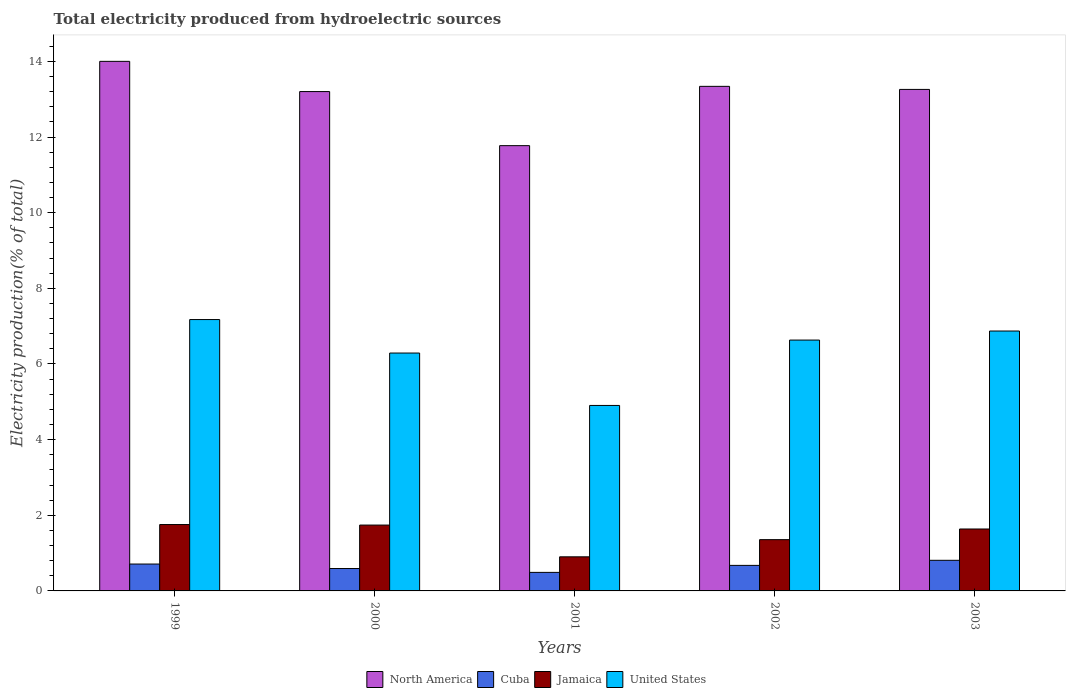How many different coloured bars are there?
Ensure brevity in your answer.  4. How many bars are there on the 3rd tick from the left?
Your response must be concise. 4. How many bars are there on the 5th tick from the right?
Ensure brevity in your answer.  4. What is the label of the 4th group of bars from the left?
Offer a terse response. 2002. What is the total electricity produced in North America in 2000?
Provide a succinct answer. 13.2. Across all years, what is the maximum total electricity produced in Cuba?
Your answer should be very brief. 0.81. Across all years, what is the minimum total electricity produced in Jamaica?
Your answer should be very brief. 0.9. In which year was the total electricity produced in Jamaica maximum?
Your response must be concise. 1999. In which year was the total electricity produced in United States minimum?
Your response must be concise. 2001. What is the total total electricity produced in United States in the graph?
Give a very brief answer. 31.87. What is the difference between the total electricity produced in Cuba in 2002 and that in 2003?
Provide a succinct answer. -0.13. What is the difference between the total electricity produced in Jamaica in 2000 and the total electricity produced in United States in 2001?
Keep it short and to the point. -3.16. What is the average total electricity produced in United States per year?
Keep it short and to the point. 6.37. In the year 2002, what is the difference between the total electricity produced in North America and total electricity produced in United States?
Offer a very short reply. 6.71. In how many years, is the total electricity produced in North America greater than 12.4 %?
Make the answer very short. 4. What is the ratio of the total electricity produced in Cuba in 2000 to that in 2002?
Your response must be concise. 0.88. Is the difference between the total electricity produced in North America in 2002 and 2003 greater than the difference between the total electricity produced in United States in 2002 and 2003?
Offer a very short reply. Yes. What is the difference between the highest and the second highest total electricity produced in Cuba?
Provide a succinct answer. 0.1. What is the difference between the highest and the lowest total electricity produced in United States?
Keep it short and to the point. 2.27. In how many years, is the total electricity produced in Jamaica greater than the average total electricity produced in Jamaica taken over all years?
Make the answer very short. 3. What does the 2nd bar from the left in 1999 represents?
Offer a very short reply. Cuba. What does the 1st bar from the right in 2001 represents?
Make the answer very short. United States. Is it the case that in every year, the sum of the total electricity produced in United States and total electricity produced in Jamaica is greater than the total electricity produced in North America?
Keep it short and to the point. No. How many bars are there?
Offer a terse response. 20. How many years are there in the graph?
Offer a very short reply. 5. Are the values on the major ticks of Y-axis written in scientific E-notation?
Provide a short and direct response. No. How many legend labels are there?
Provide a succinct answer. 4. How are the legend labels stacked?
Make the answer very short. Horizontal. What is the title of the graph?
Provide a succinct answer. Total electricity produced from hydroelectric sources. What is the Electricity production(% of total) in North America in 1999?
Ensure brevity in your answer.  14. What is the Electricity production(% of total) of Cuba in 1999?
Your response must be concise. 0.71. What is the Electricity production(% of total) of Jamaica in 1999?
Keep it short and to the point. 1.76. What is the Electricity production(% of total) in United States in 1999?
Provide a succinct answer. 7.17. What is the Electricity production(% of total) of North America in 2000?
Make the answer very short. 13.2. What is the Electricity production(% of total) of Cuba in 2000?
Keep it short and to the point. 0.59. What is the Electricity production(% of total) in Jamaica in 2000?
Give a very brief answer. 1.74. What is the Electricity production(% of total) of United States in 2000?
Ensure brevity in your answer.  6.29. What is the Electricity production(% of total) of North America in 2001?
Your answer should be very brief. 11.77. What is the Electricity production(% of total) of Cuba in 2001?
Your answer should be very brief. 0.49. What is the Electricity production(% of total) in Jamaica in 2001?
Offer a terse response. 0.9. What is the Electricity production(% of total) in United States in 2001?
Offer a terse response. 4.9. What is the Electricity production(% of total) in North America in 2002?
Your answer should be very brief. 13.34. What is the Electricity production(% of total) in Cuba in 2002?
Your response must be concise. 0.68. What is the Electricity production(% of total) in Jamaica in 2002?
Your response must be concise. 1.36. What is the Electricity production(% of total) of United States in 2002?
Give a very brief answer. 6.63. What is the Electricity production(% of total) in North America in 2003?
Provide a succinct answer. 13.26. What is the Electricity production(% of total) in Cuba in 2003?
Your answer should be very brief. 0.81. What is the Electricity production(% of total) of Jamaica in 2003?
Your answer should be very brief. 1.64. What is the Electricity production(% of total) in United States in 2003?
Provide a short and direct response. 6.87. Across all years, what is the maximum Electricity production(% of total) in North America?
Make the answer very short. 14. Across all years, what is the maximum Electricity production(% of total) in Cuba?
Your response must be concise. 0.81. Across all years, what is the maximum Electricity production(% of total) of Jamaica?
Offer a terse response. 1.76. Across all years, what is the maximum Electricity production(% of total) of United States?
Give a very brief answer. 7.17. Across all years, what is the minimum Electricity production(% of total) of North America?
Your answer should be compact. 11.77. Across all years, what is the minimum Electricity production(% of total) in Cuba?
Offer a very short reply. 0.49. Across all years, what is the minimum Electricity production(% of total) in Jamaica?
Your response must be concise. 0.9. Across all years, what is the minimum Electricity production(% of total) in United States?
Ensure brevity in your answer.  4.9. What is the total Electricity production(% of total) of North America in the graph?
Give a very brief answer. 65.58. What is the total Electricity production(% of total) in Cuba in the graph?
Ensure brevity in your answer.  3.28. What is the total Electricity production(% of total) in Jamaica in the graph?
Offer a very short reply. 7.39. What is the total Electricity production(% of total) of United States in the graph?
Ensure brevity in your answer.  31.87. What is the difference between the Electricity production(% of total) in North America in 1999 and that in 2000?
Offer a terse response. 0.8. What is the difference between the Electricity production(% of total) in Cuba in 1999 and that in 2000?
Provide a short and direct response. 0.12. What is the difference between the Electricity production(% of total) in Jamaica in 1999 and that in 2000?
Ensure brevity in your answer.  0.01. What is the difference between the Electricity production(% of total) in United States in 1999 and that in 2000?
Keep it short and to the point. 0.89. What is the difference between the Electricity production(% of total) of North America in 1999 and that in 2001?
Ensure brevity in your answer.  2.23. What is the difference between the Electricity production(% of total) of Cuba in 1999 and that in 2001?
Give a very brief answer. 0.22. What is the difference between the Electricity production(% of total) of Jamaica in 1999 and that in 2001?
Offer a terse response. 0.85. What is the difference between the Electricity production(% of total) of United States in 1999 and that in 2001?
Make the answer very short. 2.27. What is the difference between the Electricity production(% of total) in North America in 1999 and that in 2002?
Make the answer very short. 0.66. What is the difference between the Electricity production(% of total) in Cuba in 1999 and that in 2002?
Offer a very short reply. 0.04. What is the difference between the Electricity production(% of total) in Jamaica in 1999 and that in 2002?
Offer a terse response. 0.4. What is the difference between the Electricity production(% of total) of United States in 1999 and that in 2002?
Your response must be concise. 0.54. What is the difference between the Electricity production(% of total) of North America in 1999 and that in 2003?
Your answer should be very brief. 0.74. What is the difference between the Electricity production(% of total) in Cuba in 1999 and that in 2003?
Offer a very short reply. -0.1. What is the difference between the Electricity production(% of total) in Jamaica in 1999 and that in 2003?
Ensure brevity in your answer.  0.12. What is the difference between the Electricity production(% of total) of United States in 1999 and that in 2003?
Offer a very short reply. 0.3. What is the difference between the Electricity production(% of total) in North America in 2000 and that in 2001?
Your answer should be very brief. 1.43. What is the difference between the Electricity production(% of total) of Cuba in 2000 and that in 2001?
Offer a terse response. 0.1. What is the difference between the Electricity production(% of total) in Jamaica in 2000 and that in 2001?
Your answer should be very brief. 0.84. What is the difference between the Electricity production(% of total) of United States in 2000 and that in 2001?
Provide a succinct answer. 1.39. What is the difference between the Electricity production(% of total) in North America in 2000 and that in 2002?
Provide a succinct answer. -0.14. What is the difference between the Electricity production(% of total) of Cuba in 2000 and that in 2002?
Ensure brevity in your answer.  -0.08. What is the difference between the Electricity production(% of total) in Jamaica in 2000 and that in 2002?
Make the answer very short. 0.39. What is the difference between the Electricity production(% of total) in United States in 2000 and that in 2002?
Offer a terse response. -0.34. What is the difference between the Electricity production(% of total) in North America in 2000 and that in 2003?
Make the answer very short. -0.06. What is the difference between the Electricity production(% of total) in Cuba in 2000 and that in 2003?
Your answer should be very brief. -0.22. What is the difference between the Electricity production(% of total) in Jamaica in 2000 and that in 2003?
Make the answer very short. 0.1. What is the difference between the Electricity production(% of total) of United States in 2000 and that in 2003?
Your answer should be very brief. -0.58. What is the difference between the Electricity production(% of total) of North America in 2001 and that in 2002?
Ensure brevity in your answer.  -1.57. What is the difference between the Electricity production(% of total) in Cuba in 2001 and that in 2002?
Give a very brief answer. -0.18. What is the difference between the Electricity production(% of total) in Jamaica in 2001 and that in 2002?
Your answer should be very brief. -0.45. What is the difference between the Electricity production(% of total) of United States in 2001 and that in 2002?
Make the answer very short. -1.73. What is the difference between the Electricity production(% of total) of North America in 2001 and that in 2003?
Your answer should be very brief. -1.49. What is the difference between the Electricity production(% of total) in Cuba in 2001 and that in 2003?
Your answer should be compact. -0.32. What is the difference between the Electricity production(% of total) in Jamaica in 2001 and that in 2003?
Keep it short and to the point. -0.74. What is the difference between the Electricity production(% of total) of United States in 2001 and that in 2003?
Keep it short and to the point. -1.97. What is the difference between the Electricity production(% of total) in North America in 2002 and that in 2003?
Make the answer very short. 0.08. What is the difference between the Electricity production(% of total) of Cuba in 2002 and that in 2003?
Offer a very short reply. -0.13. What is the difference between the Electricity production(% of total) of Jamaica in 2002 and that in 2003?
Your answer should be very brief. -0.28. What is the difference between the Electricity production(% of total) in United States in 2002 and that in 2003?
Provide a succinct answer. -0.24. What is the difference between the Electricity production(% of total) in North America in 1999 and the Electricity production(% of total) in Cuba in 2000?
Give a very brief answer. 13.41. What is the difference between the Electricity production(% of total) in North America in 1999 and the Electricity production(% of total) in Jamaica in 2000?
Your answer should be very brief. 12.26. What is the difference between the Electricity production(% of total) of North America in 1999 and the Electricity production(% of total) of United States in 2000?
Provide a short and direct response. 7.71. What is the difference between the Electricity production(% of total) of Cuba in 1999 and the Electricity production(% of total) of Jamaica in 2000?
Your answer should be very brief. -1.03. What is the difference between the Electricity production(% of total) of Cuba in 1999 and the Electricity production(% of total) of United States in 2000?
Give a very brief answer. -5.58. What is the difference between the Electricity production(% of total) in Jamaica in 1999 and the Electricity production(% of total) in United States in 2000?
Offer a very short reply. -4.53. What is the difference between the Electricity production(% of total) in North America in 1999 and the Electricity production(% of total) in Cuba in 2001?
Keep it short and to the point. 13.51. What is the difference between the Electricity production(% of total) of North America in 1999 and the Electricity production(% of total) of Jamaica in 2001?
Make the answer very short. 13.1. What is the difference between the Electricity production(% of total) in North America in 1999 and the Electricity production(% of total) in United States in 2001?
Ensure brevity in your answer.  9.1. What is the difference between the Electricity production(% of total) in Cuba in 1999 and the Electricity production(% of total) in Jamaica in 2001?
Your answer should be very brief. -0.19. What is the difference between the Electricity production(% of total) of Cuba in 1999 and the Electricity production(% of total) of United States in 2001?
Offer a terse response. -4.19. What is the difference between the Electricity production(% of total) in Jamaica in 1999 and the Electricity production(% of total) in United States in 2001?
Keep it short and to the point. -3.15. What is the difference between the Electricity production(% of total) of North America in 1999 and the Electricity production(% of total) of Cuba in 2002?
Provide a short and direct response. 13.33. What is the difference between the Electricity production(% of total) of North America in 1999 and the Electricity production(% of total) of Jamaica in 2002?
Offer a terse response. 12.65. What is the difference between the Electricity production(% of total) of North America in 1999 and the Electricity production(% of total) of United States in 2002?
Give a very brief answer. 7.37. What is the difference between the Electricity production(% of total) of Cuba in 1999 and the Electricity production(% of total) of Jamaica in 2002?
Your response must be concise. -0.64. What is the difference between the Electricity production(% of total) of Cuba in 1999 and the Electricity production(% of total) of United States in 2002?
Provide a short and direct response. -5.92. What is the difference between the Electricity production(% of total) of Jamaica in 1999 and the Electricity production(% of total) of United States in 2002?
Ensure brevity in your answer.  -4.88. What is the difference between the Electricity production(% of total) in North America in 1999 and the Electricity production(% of total) in Cuba in 2003?
Ensure brevity in your answer.  13.19. What is the difference between the Electricity production(% of total) in North America in 1999 and the Electricity production(% of total) in Jamaica in 2003?
Make the answer very short. 12.36. What is the difference between the Electricity production(% of total) of North America in 1999 and the Electricity production(% of total) of United States in 2003?
Provide a succinct answer. 7.13. What is the difference between the Electricity production(% of total) in Cuba in 1999 and the Electricity production(% of total) in Jamaica in 2003?
Provide a succinct answer. -0.93. What is the difference between the Electricity production(% of total) of Cuba in 1999 and the Electricity production(% of total) of United States in 2003?
Provide a short and direct response. -6.16. What is the difference between the Electricity production(% of total) of Jamaica in 1999 and the Electricity production(% of total) of United States in 2003?
Provide a succinct answer. -5.12. What is the difference between the Electricity production(% of total) of North America in 2000 and the Electricity production(% of total) of Cuba in 2001?
Your response must be concise. 12.71. What is the difference between the Electricity production(% of total) of North America in 2000 and the Electricity production(% of total) of Jamaica in 2001?
Ensure brevity in your answer.  12.3. What is the difference between the Electricity production(% of total) in North America in 2000 and the Electricity production(% of total) in United States in 2001?
Provide a short and direct response. 8.3. What is the difference between the Electricity production(% of total) of Cuba in 2000 and the Electricity production(% of total) of Jamaica in 2001?
Your answer should be very brief. -0.31. What is the difference between the Electricity production(% of total) in Cuba in 2000 and the Electricity production(% of total) in United States in 2001?
Ensure brevity in your answer.  -4.31. What is the difference between the Electricity production(% of total) in Jamaica in 2000 and the Electricity production(% of total) in United States in 2001?
Keep it short and to the point. -3.16. What is the difference between the Electricity production(% of total) in North America in 2000 and the Electricity production(% of total) in Cuba in 2002?
Offer a terse response. 12.53. What is the difference between the Electricity production(% of total) of North America in 2000 and the Electricity production(% of total) of Jamaica in 2002?
Keep it short and to the point. 11.85. What is the difference between the Electricity production(% of total) in North America in 2000 and the Electricity production(% of total) in United States in 2002?
Ensure brevity in your answer.  6.57. What is the difference between the Electricity production(% of total) in Cuba in 2000 and the Electricity production(% of total) in Jamaica in 2002?
Keep it short and to the point. -0.76. What is the difference between the Electricity production(% of total) of Cuba in 2000 and the Electricity production(% of total) of United States in 2002?
Make the answer very short. -6.04. What is the difference between the Electricity production(% of total) of Jamaica in 2000 and the Electricity production(% of total) of United States in 2002?
Your answer should be very brief. -4.89. What is the difference between the Electricity production(% of total) of North America in 2000 and the Electricity production(% of total) of Cuba in 2003?
Provide a succinct answer. 12.39. What is the difference between the Electricity production(% of total) of North America in 2000 and the Electricity production(% of total) of Jamaica in 2003?
Offer a terse response. 11.56. What is the difference between the Electricity production(% of total) of North America in 2000 and the Electricity production(% of total) of United States in 2003?
Make the answer very short. 6.33. What is the difference between the Electricity production(% of total) in Cuba in 2000 and the Electricity production(% of total) in Jamaica in 2003?
Offer a very short reply. -1.05. What is the difference between the Electricity production(% of total) in Cuba in 2000 and the Electricity production(% of total) in United States in 2003?
Provide a succinct answer. -6.28. What is the difference between the Electricity production(% of total) of Jamaica in 2000 and the Electricity production(% of total) of United States in 2003?
Your response must be concise. -5.13. What is the difference between the Electricity production(% of total) in North America in 2001 and the Electricity production(% of total) in Cuba in 2002?
Your answer should be compact. 11.1. What is the difference between the Electricity production(% of total) in North America in 2001 and the Electricity production(% of total) in Jamaica in 2002?
Provide a succinct answer. 10.42. What is the difference between the Electricity production(% of total) of North America in 2001 and the Electricity production(% of total) of United States in 2002?
Your answer should be compact. 5.14. What is the difference between the Electricity production(% of total) in Cuba in 2001 and the Electricity production(% of total) in Jamaica in 2002?
Offer a very short reply. -0.87. What is the difference between the Electricity production(% of total) in Cuba in 2001 and the Electricity production(% of total) in United States in 2002?
Give a very brief answer. -6.14. What is the difference between the Electricity production(% of total) in Jamaica in 2001 and the Electricity production(% of total) in United States in 2002?
Your response must be concise. -5.73. What is the difference between the Electricity production(% of total) of North America in 2001 and the Electricity production(% of total) of Cuba in 2003?
Give a very brief answer. 10.96. What is the difference between the Electricity production(% of total) in North America in 2001 and the Electricity production(% of total) in Jamaica in 2003?
Your answer should be very brief. 10.14. What is the difference between the Electricity production(% of total) in North America in 2001 and the Electricity production(% of total) in United States in 2003?
Your answer should be very brief. 4.9. What is the difference between the Electricity production(% of total) of Cuba in 2001 and the Electricity production(% of total) of Jamaica in 2003?
Give a very brief answer. -1.15. What is the difference between the Electricity production(% of total) in Cuba in 2001 and the Electricity production(% of total) in United States in 2003?
Your answer should be compact. -6.38. What is the difference between the Electricity production(% of total) in Jamaica in 2001 and the Electricity production(% of total) in United States in 2003?
Your answer should be compact. -5.97. What is the difference between the Electricity production(% of total) in North America in 2002 and the Electricity production(% of total) in Cuba in 2003?
Ensure brevity in your answer.  12.53. What is the difference between the Electricity production(% of total) of North America in 2002 and the Electricity production(% of total) of Jamaica in 2003?
Offer a very short reply. 11.7. What is the difference between the Electricity production(% of total) of North America in 2002 and the Electricity production(% of total) of United States in 2003?
Your answer should be compact. 6.47. What is the difference between the Electricity production(% of total) in Cuba in 2002 and the Electricity production(% of total) in Jamaica in 2003?
Give a very brief answer. -0.96. What is the difference between the Electricity production(% of total) in Cuba in 2002 and the Electricity production(% of total) in United States in 2003?
Keep it short and to the point. -6.2. What is the difference between the Electricity production(% of total) of Jamaica in 2002 and the Electricity production(% of total) of United States in 2003?
Ensure brevity in your answer.  -5.52. What is the average Electricity production(% of total) in North America per year?
Your response must be concise. 13.12. What is the average Electricity production(% of total) of Cuba per year?
Offer a terse response. 0.66. What is the average Electricity production(% of total) in Jamaica per year?
Offer a very short reply. 1.48. What is the average Electricity production(% of total) of United States per year?
Provide a succinct answer. 6.37. In the year 1999, what is the difference between the Electricity production(% of total) in North America and Electricity production(% of total) in Cuba?
Give a very brief answer. 13.29. In the year 1999, what is the difference between the Electricity production(% of total) of North America and Electricity production(% of total) of Jamaica?
Your answer should be compact. 12.25. In the year 1999, what is the difference between the Electricity production(% of total) in North America and Electricity production(% of total) in United States?
Offer a terse response. 6.83. In the year 1999, what is the difference between the Electricity production(% of total) in Cuba and Electricity production(% of total) in Jamaica?
Your response must be concise. -1.04. In the year 1999, what is the difference between the Electricity production(% of total) of Cuba and Electricity production(% of total) of United States?
Offer a terse response. -6.46. In the year 1999, what is the difference between the Electricity production(% of total) of Jamaica and Electricity production(% of total) of United States?
Your answer should be very brief. -5.42. In the year 2000, what is the difference between the Electricity production(% of total) in North America and Electricity production(% of total) in Cuba?
Offer a very short reply. 12.61. In the year 2000, what is the difference between the Electricity production(% of total) of North America and Electricity production(% of total) of Jamaica?
Offer a very short reply. 11.46. In the year 2000, what is the difference between the Electricity production(% of total) in North America and Electricity production(% of total) in United States?
Provide a succinct answer. 6.91. In the year 2000, what is the difference between the Electricity production(% of total) in Cuba and Electricity production(% of total) in Jamaica?
Keep it short and to the point. -1.15. In the year 2000, what is the difference between the Electricity production(% of total) in Cuba and Electricity production(% of total) in United States?
Keep it short and to the point. -5.7. In the year 2000, what is the difference between the Electricity production(% of total) of Jamaica and Electricity production(% of total) of United States?
Offer a terse response. -4.55. In the year 2001, what is the difference between the Electricity production(% of total) in North America and Electricity production(% of total) in Cuba?
Make the answer very short. 11.28. In the year 2001, what is the difference between the Electricity production(% of total) in North America and Electricity production(% of total) in Jamaica?
Give a very brief answer. 10.87. In the year 2001, what is the difference between the Electricity production(% of total) of North America and Electricity production(% of total) of United States?
Provide a succinct answer. 6.87. In the year 2001, what is the difference between the Electricity production(% of total) of Cuba and Electricity production(% of total) of Jamaica?
Provide a succinct answer. -0.41. In the year 2001, what is the difference between the Electricity production(% of total) in Cuba and Electricity production(% of total) in United States?
Provide a short and direct response. -4.41. In the year 2001, what is the difference between the Electricity production(% of total) of Jamaica and Electricity production(% of total) of United States?
Keep it short and to the point. -4. In the year 2002, what is the difference between the Electricity production(% of total) in North America and Electricity production(% of total) in Cuba?
Offer a very short reply. 12.67. In the year 2002, what is the difference between the Electricity production(% of total) of North America and Electricity production(% of total) of Jamaica?
Your answer should be compact. 11.98. In the year 2002, what is the difference between the Electricity production(% of total) of North America and Electricity production(% of total) of United States?
Your answer should be compact. 6.71. In the year 2002, what is the difference between the Electricity production(% of total) in Cuba and Electricity production(% of total) in Jamaica?
Give a very brief answer. -0.68. In the year 2002, what is the difference between the Electricity production(% of total) of Cuba and Electricity production(% of total) of United States?
Keep it short and to the point. -5.96. In the year 2002, what is the difference between the Electricity production(% of total) of Jamaica and Electricity production(% of total) of United States?
Offer a terse response. -5.28. In the year 2003, what is the difference between the Electricity production(% of total) of North America and Electricity production(% of total) of Cuba?
Your answer should be compact. 12.45. In the year 2003, what is the difference between the Electricity production(% of total) in North America and Electricity production(% of total) in Jamaica?
Offer a very short reply. 11.62. In the year 2003, what is the difference between the Electricity production(% of total) in North America and Electricity production(% of total) in United States?
Provide a succinct answer. 6.39. In the year 2003, what is the difference between the Electricity production(% of total) in Cuba and Electricity production(% of total) in Jamaica?
Your answer should be very brief. -0.83. In the year 2003, what is the difference between the Electricity production(% of total) of Cuba and Electricity production(% of total) of United States?
Your answer should be very brief. -6.06. In the year 2003, what is the difference between the Electricity production(% of total) of Jamaica and Electricity production(% of total) of United States?
Your answer should be very brief. -5.23. What is the ratio of the Electricity production(% of total) in North America in 1999 to that in 2000?
Your answer should be very brief. 1.06. What is the ratio of the Electricity production(% of total) of Cuba in 1999 to that in 2000?
Ensure brevity in your answer.  1.2. What is the ratio of the Electricity production(% of total) in Jamaica in 1999 to that in 2000?
Keep it short and to the point. 1.01. What is the ratio of the Electricity production(% of total) in United States in 1999 to that in 2000?
Offer a very short reply. 1.14. What is the ratio of the Electricity production(% of total) in North America in 1999 to that in 2001?
Your answer should be compact. 1.19. What is the ratio of the Electricity production(% of total) of Cuba in 1999 to that in 2001?
Ensure brevity in your answer.  1.45. What is the ratio of the Electricity production(% of total) in Jamaica in 1999 to that in 2001?
Keep it short and to the point. 1.95. What is the ratio of the Electricity production(% of total) of United States in 1999 to that in 2001?
Make the answer very short. 1.46. What is the ratio of the Electricity production(% of total) in North America in 1999 to that in 2002?
Provide a succinct answer. 1.05. What is the ratio of the Electricity production(% of total) in Cuba in 1999 to that in 2002?
Give a very brief answer. 1.05. What is the ratio of the Electricity production(% of total) in Jamaica in 1999 to that in 2002?
Your response must be concise. 1.29. What is the ratio of the Electricity production(% of total) in United States in 1999 to that in 2002?
Make the answer very short. 1.08. What is the ratio of the Electricity production(% of total) in North America in 1999 to that in 2003?
Provide a succinct answer. 1.06. What is the ratio of the Electricity production(% of total) of Cuba in 1999 to that in 2003?
Ensure brevity in your answer.  0.88. What is the ratio of the Electricity production(% of total) of Jamaica in 1999 to that in 2003?
Make the answer very short. 1.07. What is the ratio of the Electricity production(% of total) of United States in 1999 to that in 2003?
Keep it short and to the point. 1.04. What is the ratio of the Electricity production(% of total) of North America in 2000 to that in 2001?
Offer a very short reply. 1.12. What is the ratio of the Electricity production(% of total) of Cuba in 2000 to that in 2001?
Offer a very short reply. 1.21. What is the ratio of the Electricity production(% of total) in Jamaica in 2000 to that in 2001?
Offer a terse response. 1.93. What is the ratio of the Electricity production(% of total) of United States in 2000 to that in 2001?
Offer a terse response. 1.28. What is the ratio of the Electricity production(% of total) of North America in 2000 to that in 2002?
Your answer should be compact. 0.99. What is the ratio of the Electricity production(% of total) of Cuba in 2000 to that in 2002?
Offer a very short reply. 0.88. What is the ratio of the Electricity production(% of total) of Jamaica in 2000 to that in 2002?
Give a very brief answer. 1.28. What is the ratio of the Electricity production(% of total) of United States in 2000 to that in 2002?
Provide a short and direct response. 0.95. What is the ratio of the Electricity production(% of total) in Cuba in 2000 to that in 2003?
Offer a terse response. 0.73. What is the ratio of the Electricity production(% of total) in Jamaica in 2000 to that in 2003?
Give a very brief answer. 1.06. What is the ratio of the Electricity production(% of total) in United States in 2000 to that in 2003?
Make the answer very short. 0.92. What is the ratio of the Electricity production(% of total) in North America in 2001 to that in 2002?
Your answer should be very brief. 0.88. What is the ratio of the Electricity production(% of total) in Cuba in 2001 to that in 2002?
Keep it short and to the point. 0.73. What is the ratio of the Electricity production(% of total) in Jamaica in 2001 to that in 2002?
Your answer should be compact. 0.67. What is the ratio of the Electricity production(% of total) of United States in 2001 to that in 2002?
Offer a terse response. 0.74. What is the ratio of the Electricity production(% of total) of North America in 2001 to that in 2003?
Your response must be concise. 0.89. What is the ratio of the Electricity production(% of total) of Cuba in 2001 to that in 2003?
Offer a terse response. 0.61. What is the ratio of the Electricity production(% of total) of Jamaica in 2001 to that in 2003?
Your answer should be compact. 0.55. What is the ratio of the Electricity production(% of total) in United States in 2001 to that in 2003?
Offer a very short reply. 0.71. What is the ratio of the Electricity production(% of total) of North America in 2002 to that in 2003?
Your answer should be compact. 1.01. What is the ratio of the Electricity production(% of total) of Cuba in 2002 to that in 2003?
Offer a very short reply. 0.83. What is the ratio of the Electricity production(% of total) of Jamaica in 2002 to that in 2003?
Give a very brief answer. 0.83. What is the ratio of the Electricity production(% of total) of United States in 2002 to that in 2003?
Give a very brief answer. 0.97. What is the difference between the highest and the second highest Electricity production(% of total) in North America?
Your response must be concise. 0.66. What is the difference between the highest and the second highest Electricity production(% of total) in Cuba?
Offer a very short reply. 0.1. What is the difference between the highest and the second highest Electricity production(% of total) in Jamaica?
Ensure brevity in your answer.  0.01. What is the difference between the highest and the second highest Electricity production(% of total) of United States?
Give a very brief answer. 0.3. What is the difference between the highest and the lowest Electricity production(% of total) of North America?
Your answer should be compact. 2.23. What is the difference between the highest and the lowest Electricity production(% of total) in Cuba?
Your response must be concise. 0.32. What is the difference between the highest and the lowest Electricity production(% of total) in Jamaica?
Give a very brief answer. 0.85. What is the difference between the highest and the lowest Electricity production(% of total) of United States?
Ensure brevity in your answer.  2.27. 